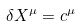<formula> <loc_0><loc_0><loc_500><loc_500>\delta X ^ { \mu } = c ^ { \mu }</formula> 